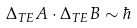Convert formula to latex. <formula><loc_0><loc_0><loc_500><loc_500>\Delta _ { T E } A \cdot \Delta _ { T E } B \sim \hbar</formula> 